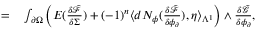<formula> <loc_0><loc_0><loc_500><loc_500>\begin{array} { r l } { = } & \int _ { \partial \Omega } \left ( E ( \frac { \delta \tilde { \mathcal { F } } } { \delta \Sigma } ) + ( - 1 ) ^ { n } \langle d N _ { \phi } ( \frac { \delta \tilde { \mathcal { F } } } { \delta \phi _ { \partial } } ) , \eta \rangle _ { \Lambda ^ { 1 } } \right ) \wedge \frac { \delta \tilde { \mathcal { G } } } { \delta \phi _ { \partial } } , } \end{array}</formula> 